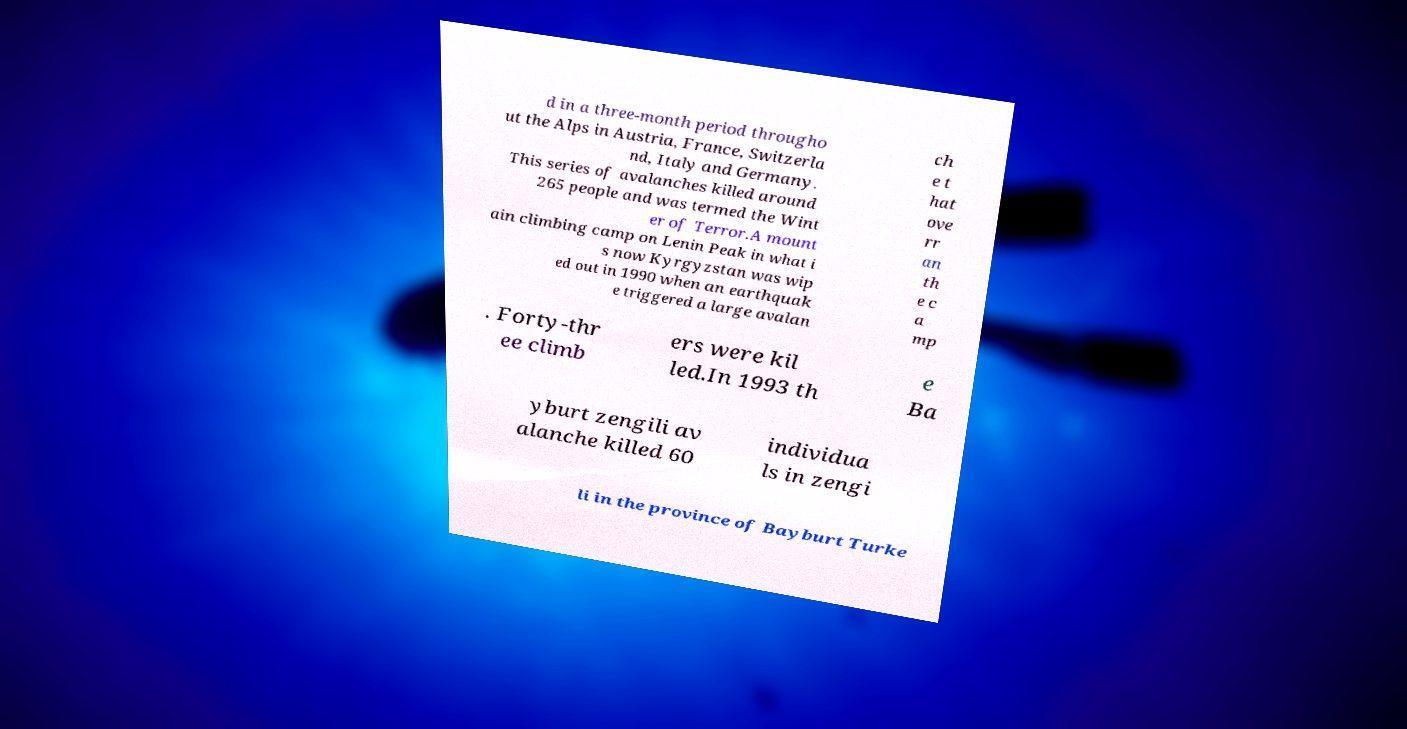Could you extract and type out the text from this image? d in a three-month period througho ut the Alps in Austria, France, Switzerla nd, Italy and Germany. This series of avalanches killed around 265 people and was termed the Wint er of Terror.A mount ain climbing camp on Lenin Peak in what i s now Kyrgyzstan was wip ed out in 1990 when an earthquak e triggered a large avalan ch e t hat ove rr an th e c a mp . Forty-thr ee climb ers were kil led.In 1993 th e Ba yburt zengili av alanche killed 60 individua ls in zengi li in the province of Bayburt Turke 